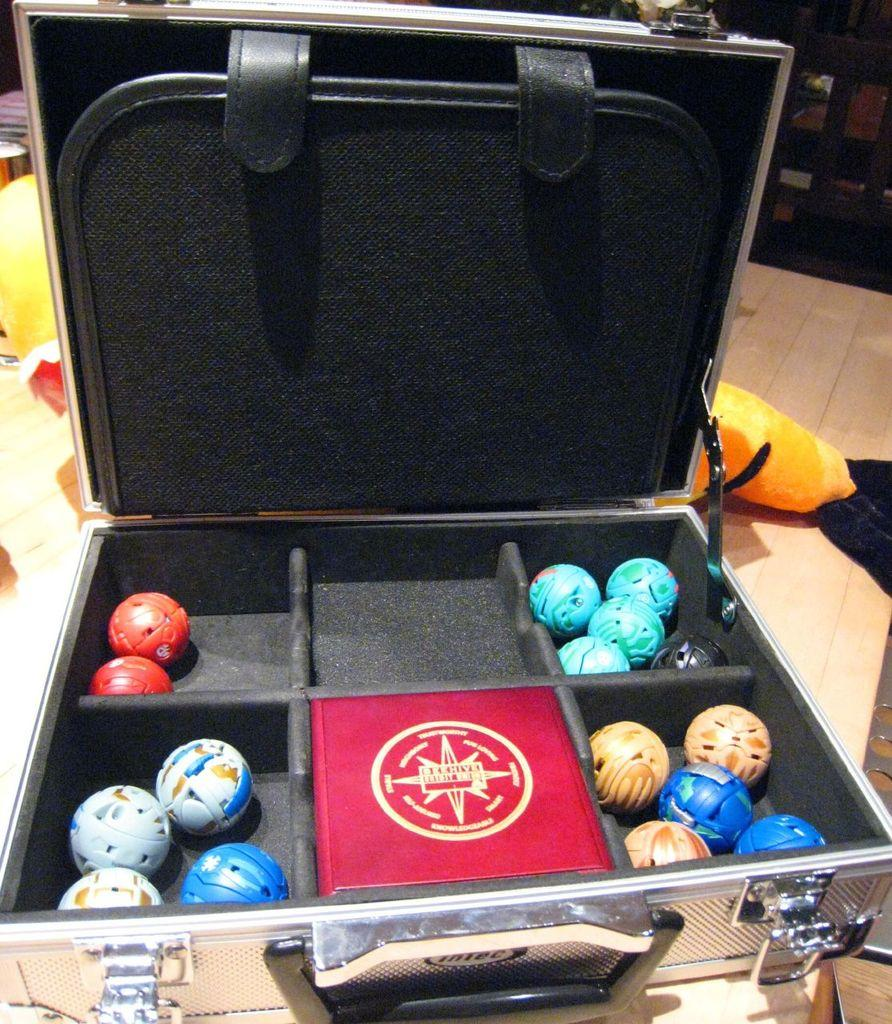What is the main object in the image? There is a box in the image. Can you describe the box in more detail? The box has segments. What can be found inside the segments of the box? The segments contain small balls. How many bulbs are hanging from the street in the image? There are no bulbs or streets present in the image; it features a box with segments containing small balls. 